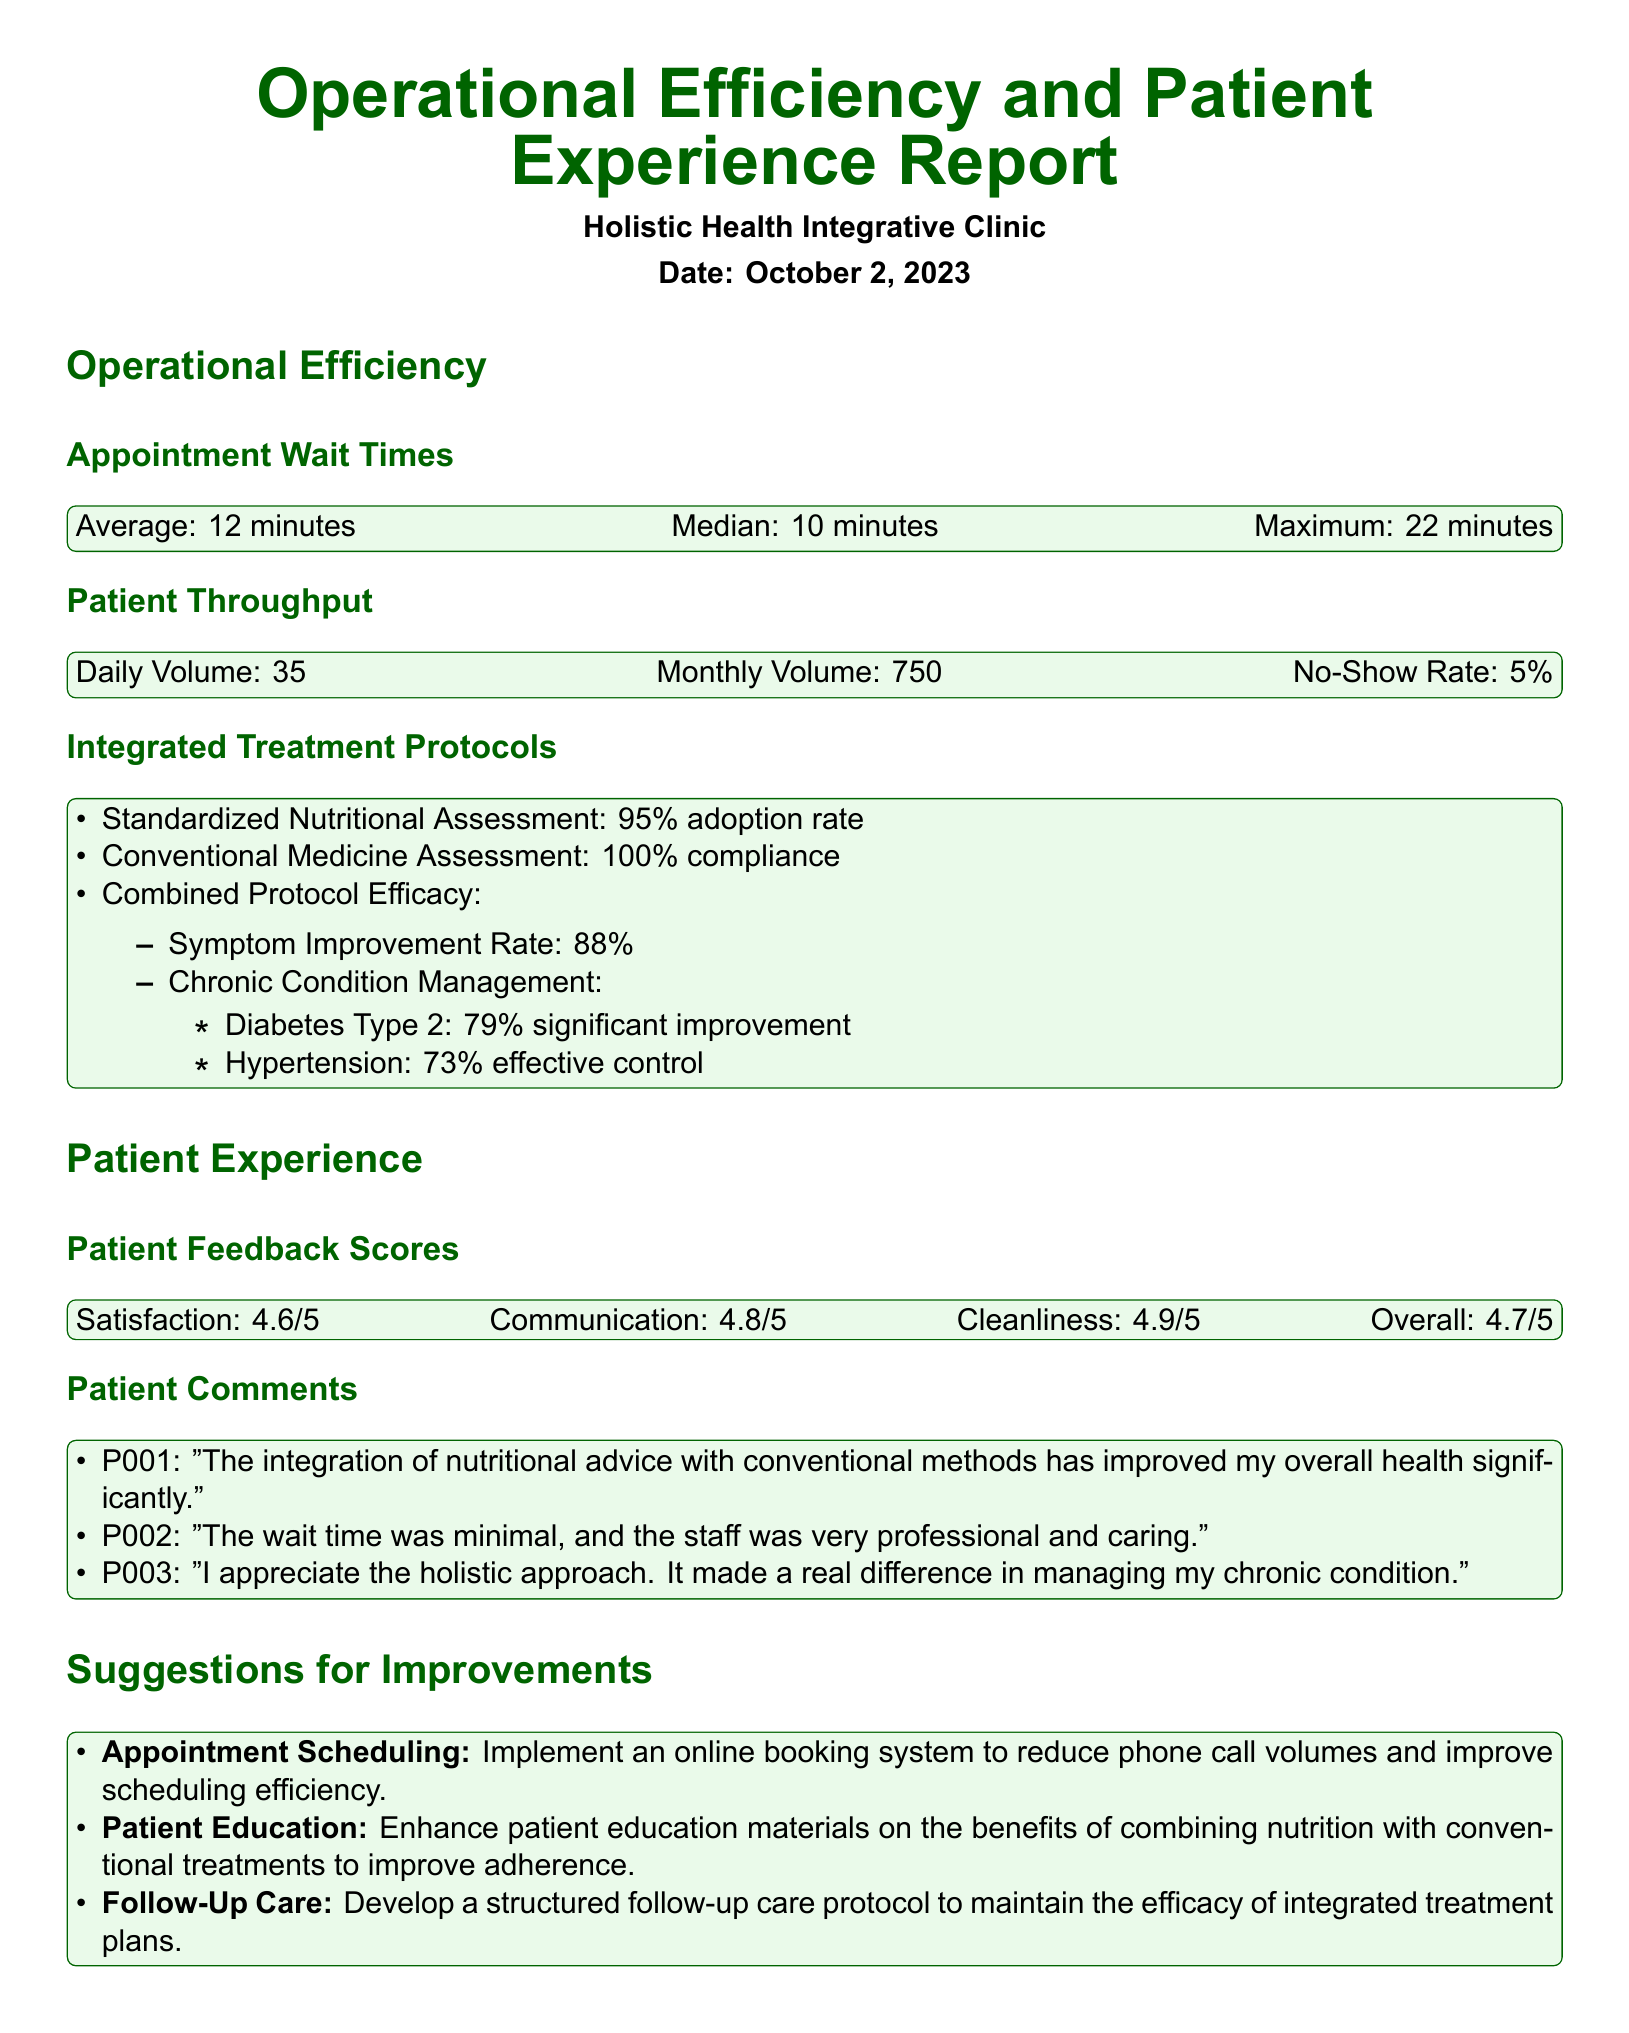what is the average appointment wait time? The average appointment wait time is provided under the Appointment Wait Times section, which states it is 12 minutes.
Answer: 12 minutes what percentage of patients experienced significant improvement in diabetes type 2 management? The document includes a statistic under Integrated Treatment Protocols that indicates a 79% significant improvement in diabetes type 2 management.
Answer: 79% how many patients does the clinic see daily? The Daily Volume under Patient Throughput section specifies that the clinic sees 35 patients each day.
Answer: 35 what is the overall patient feedback score? The Overall score under Patient Feedback Scores states that it is 4.7 out of 5.
Answer: 4.7/5 what is one suggestion for improving appointment scheduling? The Suggestions for Improvements section mentions implementing an online booking system as a way to enhance appointment scheduling.
Answer: Online booking system how clean is the clinic according to patient feedback? The Cleanliness score under Patient Feedback Scores indicates a score of 4.9 out of 5.
Answer: 4.9/5 what is the average monthly patient volume? The Monthly Volume stated in the Patient Throughput section shows that the clinic sees 750 patients per month.
Answer: 750 which protocol has a 100% compliance rate? The Conventional Medicine Assessment is noted to have a 100% compliance rate under Integrated Treatment Protocols.
Answer: Conventional Medicine Assessment what is the no-show rate at the clinic? The No-Show Rate provided in the Patient Throughput section indicates it is 5%.
Answer: 5% 